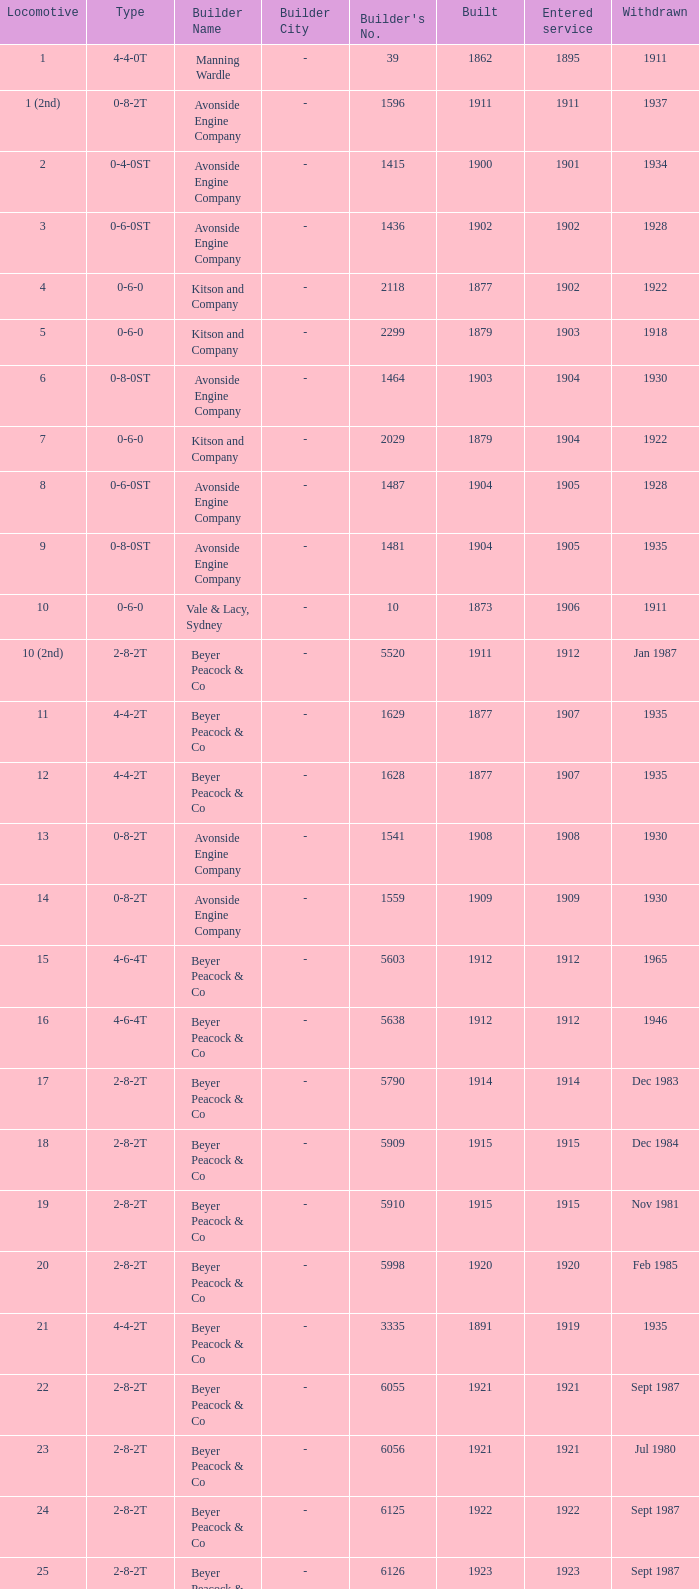How many years entered service when there were 13 locomotives? 1.0. 